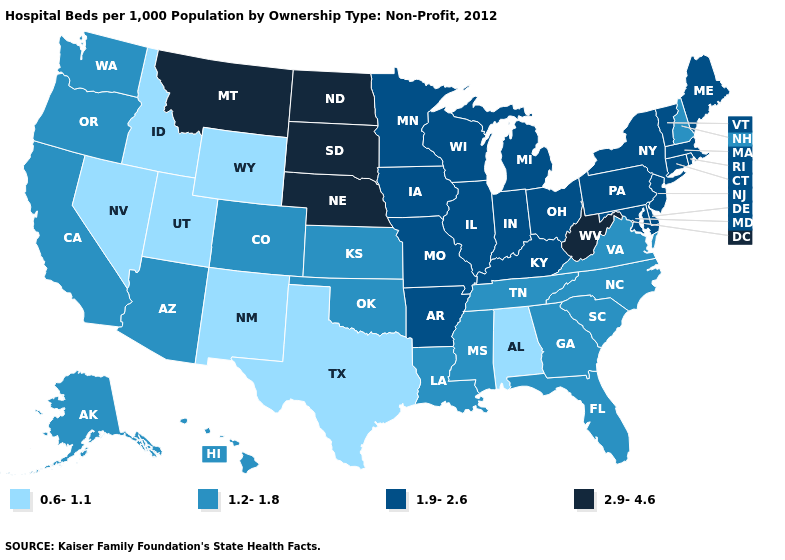Which states have the lowest value in the Northeast?
Answer briefly. New Hampshire. Name the states that have a value in the range 1.2-1.8?
Short answer required. Alaska, Arizona, California, Colorado, Florida, Georgia, Hawaii, Kansas, Louisiana, Mississippi, New Hampshire, North Carolina, Oklahoma, Oregon, South Carolina, Tennessee, Virginia, Washington. What is the value of Arizona?
Answer briefly. 1.2-1.8. What is the highest value in the USA?
Answer briefly. 2.9-4.6. Name the states that have a value in the range 2.9-4.6?
Concise answer only. Montana, Nebraska, North Dakota, South Dakota, West Virginia. Name the states that have a value in the range 1.2-1.8?
Keep it brief. Alaska, Arizona, California, Colorado, Florida, Georgia, Hawaii, Kansas, Louisiana, Mississippi, New Hampshire, North Carolina, Oklahoma, Oregon, South Carolina, Tennessee, Virginia, Washington. Does the first symbol in the legend represent the smallest category?
Short answer required. Yes. Which states have the highest value in the USA?
Be succinct. Montana, Nebraska, North Dakota, South Dakota, West Virginia. Name the states that have a value in the range 0.6-1.1?
Give a very brief answer. Alabama, Idaho, Nevada, New Mexico, Texas, Utah, Wyoming. What is the value of New Hampshire?
Quick response, please. 1.2-1.8. How many symbols are there in the legend?
Give a very brief answer. 4. What is the value of Florida?
Be succinct. 1.2-1.8. What is the value of Colorado?
Short answer required. 1.2-1.8. Does Nebraska have the highest value in the MidWest?
Answer briefly. Yes. What is the highest value in the USA?
Give a very brief answer. 2.9-4.6. 